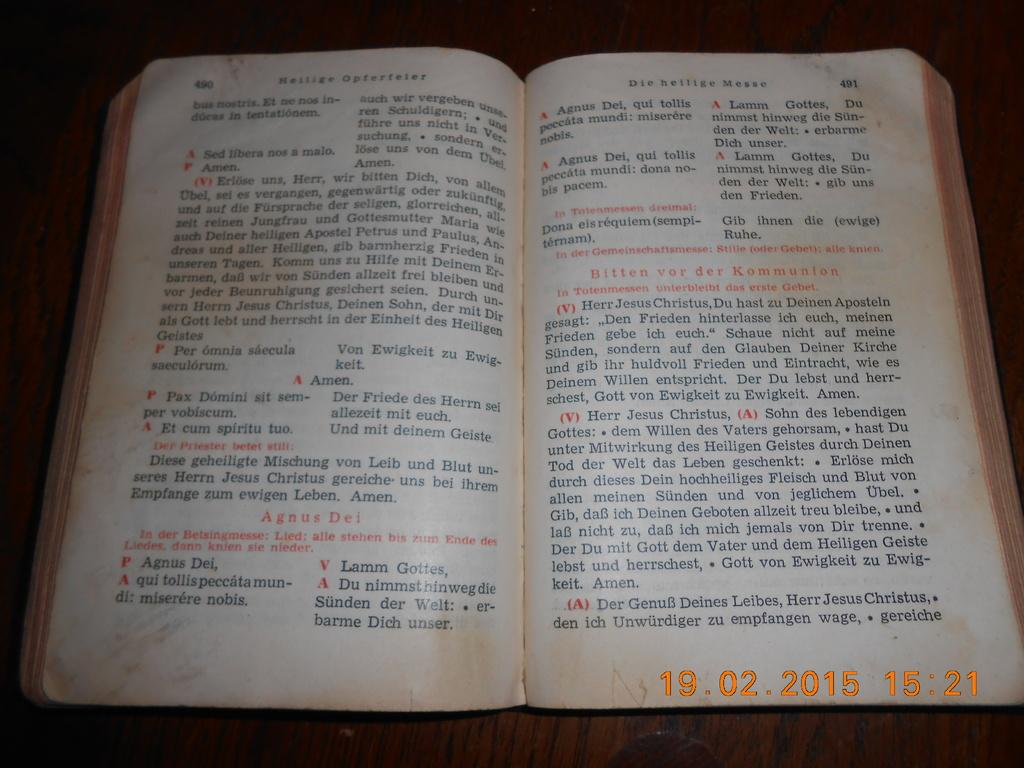<image>
Describe the image concisely. A Bible lays opened up on a table written in foreign language like Herr Jesus Christus, Du Hast zu Deinem. 